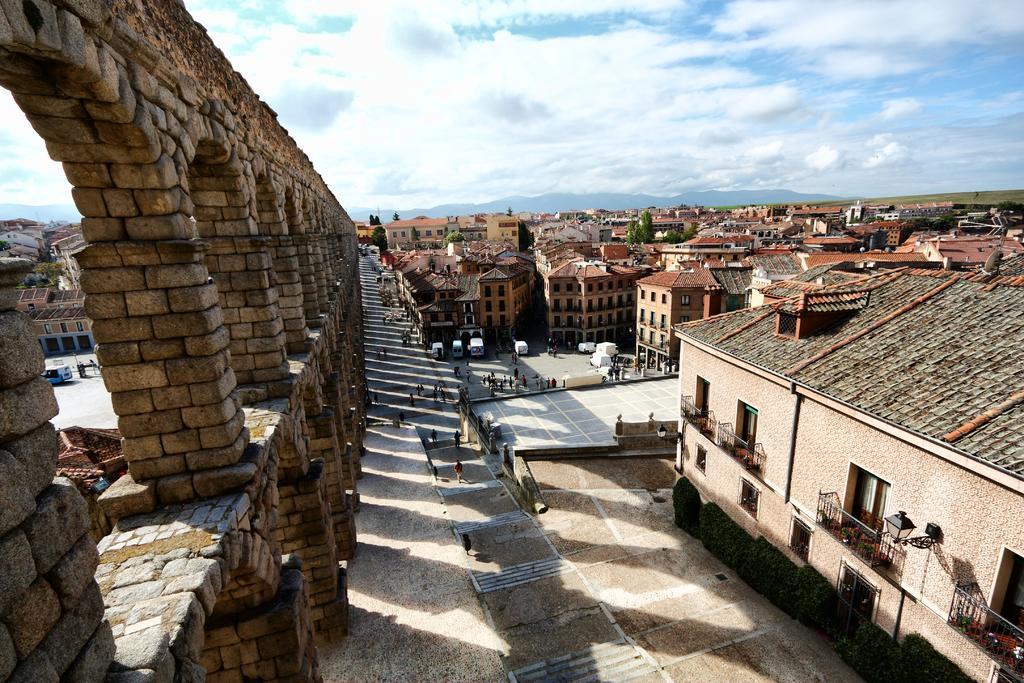Could you give a brief overview of what you see in this image? In the foreground of this image, there are building, trees, people on the ground, the sky and the cloud. On the left side of the image, there is a wall. 